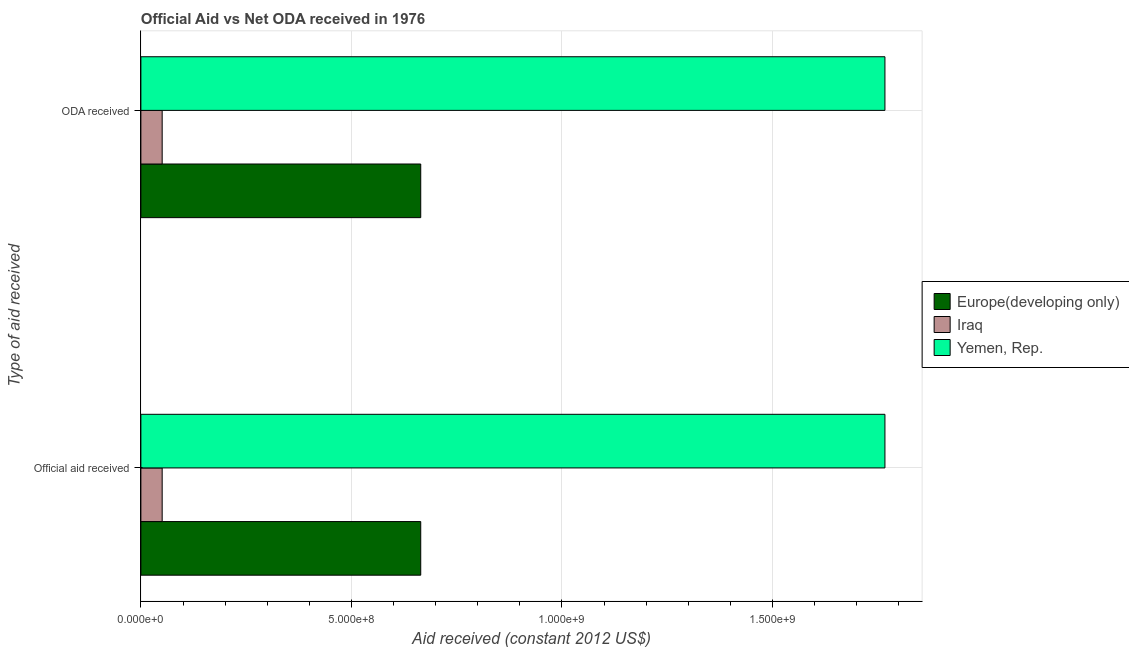How many different coloured bars are there?
Give a very brief answer. 3. How many groups of bars are there?
Provide a short and direct response. 2. Are the number of bars on each tick of the Y-axis equal?
Offer a terse response. Yes. What is the label of the 2nd group of bars from the top?
Your response must be concise. Official aid received. What is the oda received in Europe(developing only)?
Provide a succinct answer. 6.65e+08. Across all countries, what is the maximum oda received?
Offer a very short reply. 1.77e+09. Across all countries, what is the minimum oda received?
Give a very brief answer. 5.06e+07. In which country was the oda received maximum?
Give a very brief answer. Yemen, Rep. In which country was the oda received minimum?
Your response must be concise. Iraq. What is the total official aid received in the graph?
Keep it short and to the point. 2.48e+09. What is the difference between the oda received in Yemen, Rep. and that in Europe(developing only)?
Make the answer very short. 1.10e+09. What is the difference between the oda received in Yemen, Rep. and the official aid received in Europe(developing only)?
Make the answer very short. 1.10e+09. What is the average official aid received per country?
Ensure brevity in your answer.  8.27e+08. What is the ratio of the official aid received in Iraq to that in Yemen, Rep.?
Your answer should be compact. 0.03. Is the oda received in Yemen, Rep. less than that in Iraq?
Your answer should be very brief. No. In how many countries, is the oda received greater than the average oda received taken over all countries?
Your response must be concise. 1. What does the 3rd bar from the top in ODA received represents?
Your answer should be compact. Europe(developing only). What does the 3rd bar from the bottom in ODA received represents?
Give a very brief answer. Yemen, Rep. Are all the bars in the graph horizontal?
Provide a succinct answer. Yes. How many countries are there in the graph?
Provide a short and direct response. 3. Are the values on the major ticks of X-axis written in scientific E-notation?
Your answer should be very brief. Yes. Does the graph contain any zero values?
Offer a terse response. No. What is the title of the graph?
Your response must be concise. Official Aid vs Net ODA received in 1976 . Does "Grenada" appear as one of the legend labels in the graph?
Provide a succinct answer. No. What is the label or title of the X-axis?
Offer a terse response. Aid received (constant 2012 US$). What is the label or title of the Y-axis?
Provide a short and direct response. Type of aid received. What is the Aid received (constant 2012 US$) in Europe(developing only) in Official aid received?
Offer a terse response. 6.65e+08. What is the Aid received (constant 2012 US$) of Iraq in Official aid received?
Your answer should be compact. 5.06e+07. What is the Aid received (constant 2012 US$) in Yemen, Rep. in Official aid received?
Your answer should be very brief. 1.77e+09. What is the Aid received (constant 2012 US$) of Europe(developing only) in ODA received?
Your answer should be very brief. 6.65e+08. What is the Aid received (constant 2012 US$) in Iraq in ODA received?
Your response must be concise. 5.06e+07. What is the Aid received (constant 2012 US$) in Yemen, Rep. in ODA received?
Provide a short and direct response. 1.77e+09. Across all Type of aid received, what is the maximum Aid received (constant 2012 US$) of Europe(developing only)?
Ensure brevity in your answer.  6.65e+08. Across all Type of aid received, what is the maximum Aid received (constant 2012 US$) of Iraq?
Your answer should be very brief. 5.06e+07. Across all Type of aid received, what is the maximum Aid received (constant 2012 US$) of Yemen, Rep.?
Ensure brevity in your answer.  1.77e+09. Across all Type of aid received, what is the minimum Aid received (constant 2012 US$) of Europe(developing only)?
Offer a terse response. 6.65e+08. Across all Type of aid received, what is the minimum Aid received (constant 2012 US$) of Iraq?
Give a very brief answer. 5.06e+07. Across all Type of aid received, what is the minimum Aid received (constant 2012 US$) of Yemen, Rep.?
Keep it short and to the point. 1.77e+09. What is the total Aid received (constant 2012 US$) of Europe(developing only) in the graph?
Your response must be concise. 1.33e+09. What is the total Aid received (constant 2012 US$) in Iraq in the graph?
Give a very brief answer. 1.01e+08. What is the total Aid received (constant 2012 US$) in Yemen, Rep. in the graph?
Give a very brief answer. 3.53e+09. What is the difference between the Aid received (constant 2012 US$) in Europe(developing only) in Official aid received and that in ODA received?
Your answer should be compact. 0. What is the difference between the Aid received (constant 2012 US$) of Yemen, Rep. in Official aid received and that in ODA received?
Give a very brief answer. 0. What is the difference between the Aid received (constant 2012 US$) in Europe(developing only) in Official aid received and the Aid received (constant 2012 US$) in Iraq in ODA received?
Your answer should be very brief. 6.14e+08. What is the difference between the Aid received (constant 2012 US$) of Europe(developing only) in Official aid received and the Aid received (constant 2012 US$) of Yemen, Rep. in ODA received?
Your answer should be compact. -1.10e+09. What is the difference between the Aid received (constant 2012 US$) in Iraq in Official aid received and the Aid received (constant 2012 US$) in Yemen, Rep. in ODA received?
Provide a succinct answer. -1.72e+09. What is the average Aid received (constant 2012 US$) of Europe(developing only) per Type of aid received?
Offer a terse response. 6.65e+08. What is the average Aid received (constant 2012 US$) in Iraq per Type of aid received?
Provide a short and direct response. 5.06e+07. What is the average Aid received (constant 2012 US$) in Yemen, Rep. per Type of aid received?
Your answer should be compact. 1.77e+09. What is the difference between the Aid received (constant 2012 US$) of Europe(developing only) and Aid received (constant 2012 US$) of Iraq in Official aid received?
Provide a short and direct response. 6.14e+08. What is the difference between the Aid received (constant 2012 US$) of Europe(developing only) and Aid received (constant 2012 US$) of Yemen, Rep. in Official aid received?
Keep it short and to the point. -1.10e+09. What is the difference between the Aid received (constant 2012 US$) of Iraq and Aid received (constant 2012 US$) of Yemen, Rep. in Official aid received?
Give a very brief answer. -1.72e+09. What is the difference between the Aid received (constant 2012 US$) of Europe(developing only) and Aid received (constant 2012 US$) of Iraq in ODA received?
Offer a very short reply. 6.14e+08. What is the difference between the Aid received (constant 2012 US$) of Europe(developing only) and Aid received (constant 2012 US$) of Yemen, Rep. in ODA received?
Your answer should be compact. -1.10e+09. What is the difference between the Aid received (constant 2012 US$) of Iraq and Aid received (constant 2012 US$) of Yemen, Rep. in ODA received?
Provide a succinct answer. -1.72e+09. What is the ratio of the Aid received (constant 2012 US$) of Yemen, Rep. in Official aid received to that in ODA received?
Offer a very short reply. 1. What is the difference between the highest and the second highest Aid received (constant 2012 US$) of Europe(developing only)?
Ensure brevity in your answer.  0. What is the difference between the highest and the second highest Aid received (constant 2012 US$) of Iraq?
Your answer should be compact. 0. What is the difference between the highest and the second highest Aid received (constant 2012 US$) of Yemen, Rep.?
Provide a succinct answer. 0. What is the difference between the highest and the lowest Aid received (constant 2012 US$) of Iraq?
Your answer should be very brief. 0. What is the difference between the highest and the lowest Aid received (constant 2012 US$) of Yemen, Rep.?
Provide a short and direct response. 0. 